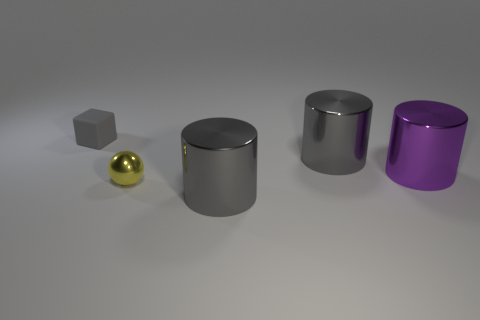Subtract all purple metallic cylinders. How many cylinders are left? 2 Add 3 small cyan cylinders. How many objects exist? 8 Subtract all yellow balls. How many gray cylinders are left? 2 Subtract all cylinders. How many objects are left? 2 Add 3 spheres. How many spheres are left? 4 Add 3 yellow metallic spheres. How many yellow metallic spheres exist? 4 Subtract 0 red cylinders. How many objects are left? 5 Subtract all purple cubes. Subtract all gray balls. How many cubes are left? 1 Subtract all tiny cyan matte cubes. Subtract all large gray things. How many objects are left? 3 